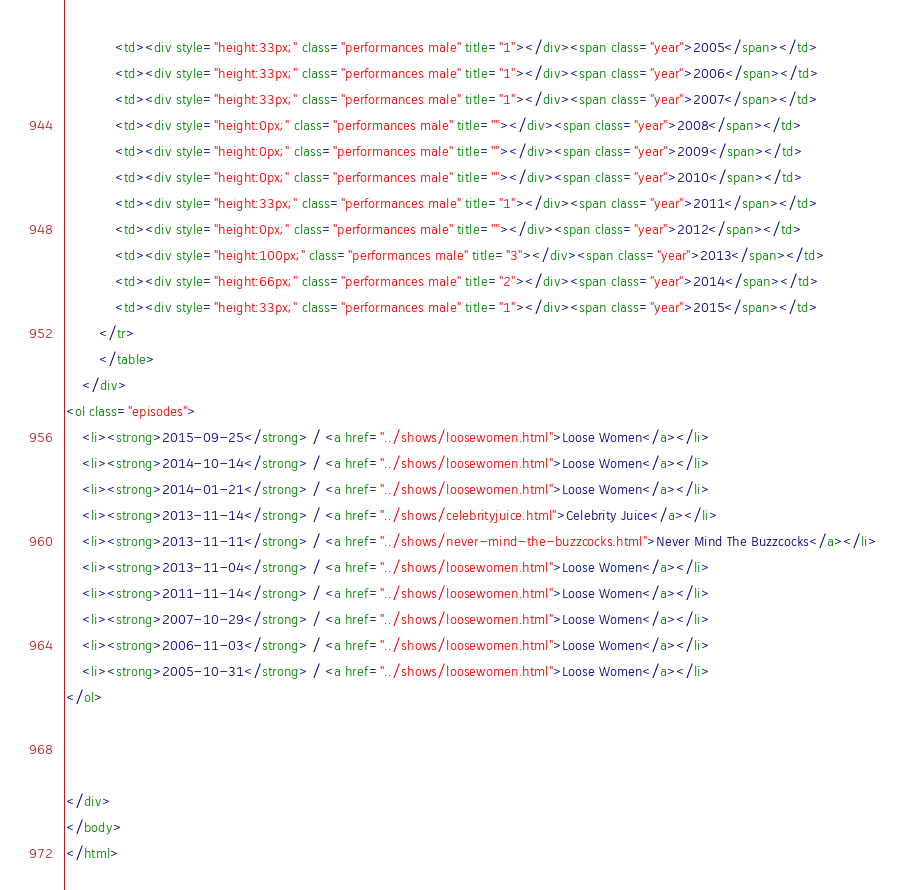Convert code to text. <code><loc_0><loc_0><loc_500><loc_500><_HTML_>			<td><div style="height:33px;" class="performances male" title="1"></div><span class="year">2005</span></td>
			<td><div style="height:33px;" class="performances male" title="1"></div><span class="year">2006</span></td>
			<td><div style="height:33px;" class="performances male" title="1"></div><span class="year">2007</span></td>
			<td><div style="height:0px;" class="performances male" title=""></div><span class="year">2008</span></td>
			<td><div style="height:0px;" class="performances male" title=""></div><span class="year">2009</span></td>
			<td><div style="height:0px;" class="performances male" title=""></div><span class="year">2010</span></td>
			<td><div style="height:33px;" class="performances male" title="1"></div><span class="year">2011</span></td>
			<td><div style="height:0px;" class="performances male" title=""></div><span class="year">2012</span></td>
			<td><div style="height:100px;" class="performances male" title="3"></div><span class="year">2013</span></td>
			<td><div style="height:66px;" class="performances male" title="2"></div><span class="year">2014</span></td>
			<td><div style="height:33px;" class="performances male" title="1"></div><span class="year">2015</span></td>
		</tr>
		</table>
	</div>
<ol class="episodes">
	<li><strong>2015-09-25</strong> / <a href="../shows/loosewomen.html">Loose Women</a></li>
	<li><strong>2014-10-14</strong> / <a href="../shows/loosewomen.html">Loose Women</a></li>
	<li><strong>2014-01-21</strong> / <a href="../shows/loosewomen.html">Loose Women</a></li>
	<li><strong>2013-11-14</strong> / <a href="../shows/celebrityjuice.html">Celebrity Juice</a></li>
	<li><strong>2013-11-11</strong> / <a href="../shows/never-mind-the-buzzcocks.html">Never Mind The Buzzcocks</a></li>
	<li><strong>2013-11-04</strong> / <a href="../shows/loosewomen.html">Loose Women</a></li>
	<li><strong>2011-11-14</strong> / <a href="../shows/loosewomen.html">Loose Women</a></li>
	<li><strong>2007-10-29</strong> / <a href="../shows/loosewomen.html">Loose Women</a></li>
	<li><strong>2006-11-03</strong> / <a href="../shows/loosewomen.html">Loose Women</a></li>
	<li><strong>2005-10-31</strong> / <a href="../shows/loosewomen.html">Loose Women</a></li>
</ol>



</div>
</body>
</html>
</code> 